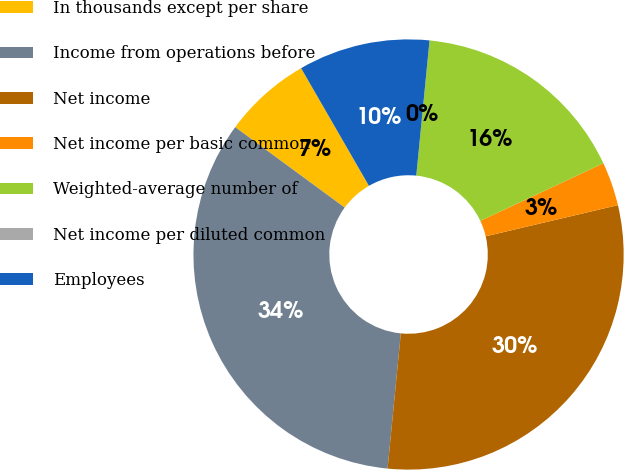Convert chart. <chart><loc_0><loc_0><loc_500><loc_500><pie_chart><fcel>In thousands except per share<fcel>Income from operations before<fcel>Net income<fcel>Net income per basic common<fcel>Weighted-average number of<fcel>Net income per diluted common<fcel>Employees<nl><fcel>6.59%<fcel>33.53%<fcel>30.24%<fcel>3.29%<fcel>16.47%<fcel>0.0%<fcel>9.88%<nl></chart> 